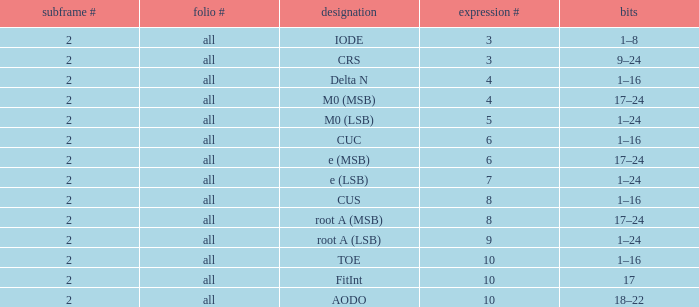What is the total subframe count with Bits of 18–22? 2.0. 